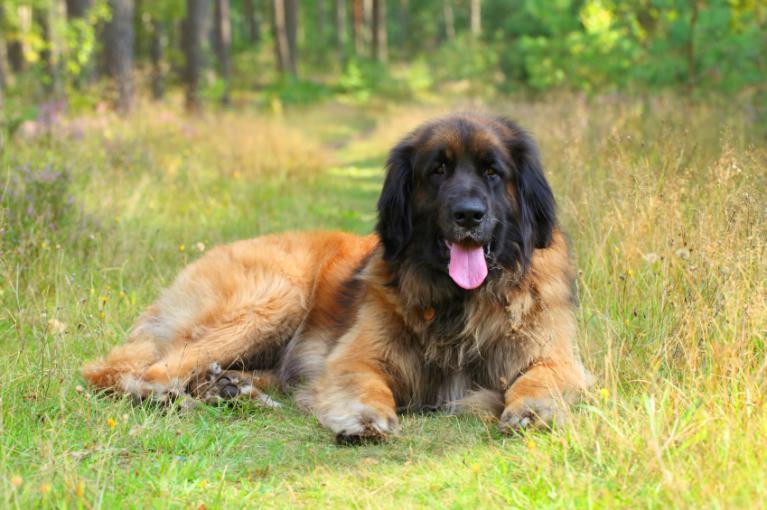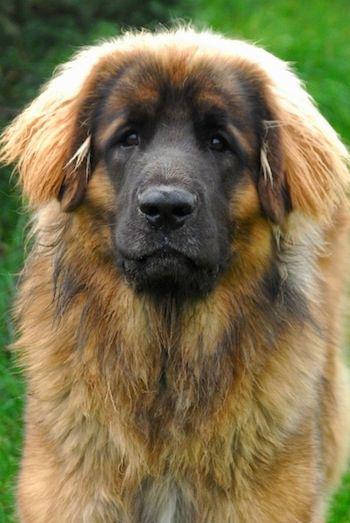The first image is the image on the left, the second image is the image on the right. Examine the images to the left and right. Is the description "There is one dog tongue in the image on the left." accurate? Answer yes or no. Yes. 